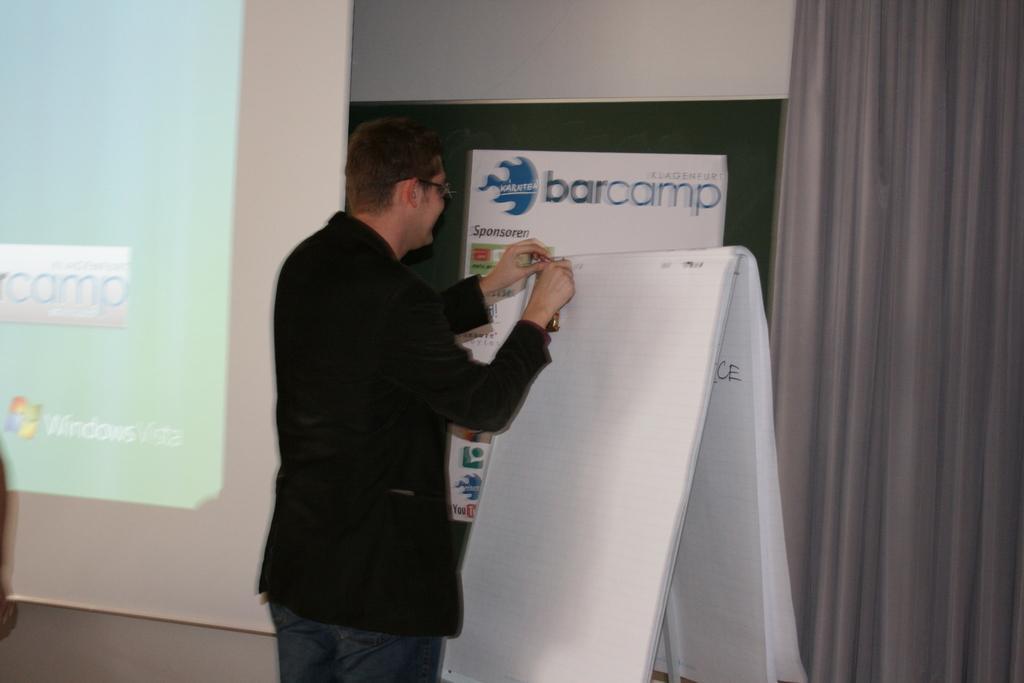Please provide a concise description of this image. In this image we can see a person standing and in front of him there is a board and on the left side of the image we can see a projector screen. There is a wall with poster with some text and we can see a curtain on the right side of the image. 